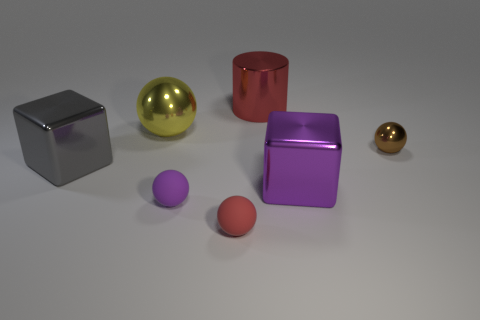What is the material of the ball that is the same color as the cylinder?
Offer a very short reply. Rubber. What number of shiny things are both left of the brown metallic object and to the right of the red cylinder?
Provide a succinct answer. 1. What material is the yellow object right of the metal object on the left side of the large yellow object?
Your response must be concise. Metal. Are there any large brown cylinders made of the same material as the red sphere?
Offer a terse response. No. There is a block that is the same size as the purple metal object; what is its material?
Keep it short and to the point. Metal. There is a red object that is behind the small thing behind the metallic cube that is on the left side of the purple cube; what is its size?
Your answer should be compact. Large. Are there any big purple objects behind the tiny sphere right of the large purple object?
Provide a short and direct response. No. There is a purple rubber object; is its shape the same as the purple thing on the right side of the purple matte ball?
Your answer should be compact. No. The cube that is in front of the gray metal block is what color?
Provide a short and direct response. Purple. How big is the metallic ball that is right of the purple object that is behind the tiny purple rubber object?
Your answer should be very brief. Small. 